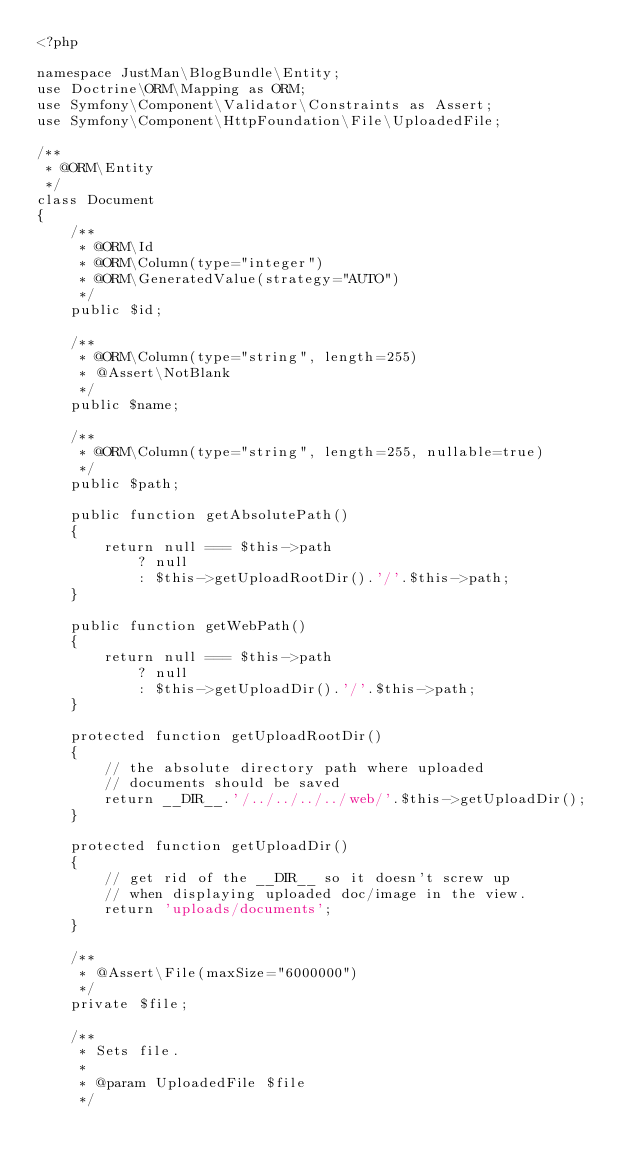Convert code to text. <code><loc_0><loc_0><loc_500><loc_500><_PHP_><?php

namespace JustMan\BlogBundle\Entity;
use Doctrine\ORM\Mapping as ORM;
use Symfony\Component\Validator\Constraints as Assert;
use Symfony\Component\HttpFoundation\File\UploadedFile;

/**
 * @ORM\Entity
 */
class Document
{
    /**
     * @ORM\Id
     * @ORM\Column(type="integer")
     * @ORM\GeneratedValue(strategy="AUTO")
     */
    public $id;

    /**
     * @ORM\Column(type="string", length=255)
     * @Assert\NotBlank
     */
    public $name;

    /**
     * @ORM\Column(type="string", length=255, nullable=true)
     */
    public $path;

    public function getAbsolutePath()
    {
        return null === $this->path
            ? null
            : $this->getUploadRootDir().'/'.$this->path;
    }

    public function getWebPath()
    {
        return null === $this->path
            ? null
            : $this->getUploadDir().'/'.$this->path;
    }

    protected function getUploadRootDir()
    {
        // the absolute directory path where uploaded
        // documents should be saved
        return __DIR__.'/../../../../web/'.$this->getUploadDir();
    }

    protected function getUploadDir()
    {
        // get rid of the __DIR__ so it doesn't screw up
        // when displaying uploaded doc/image in the view.
        return 'uploads/documents';
    }

    /**
     * @Assert\File(maxSize="6000000")
     */
    private $file;

    /**
     * Sets file.
     *
     * @param UploadedFile $file
     */</code> 